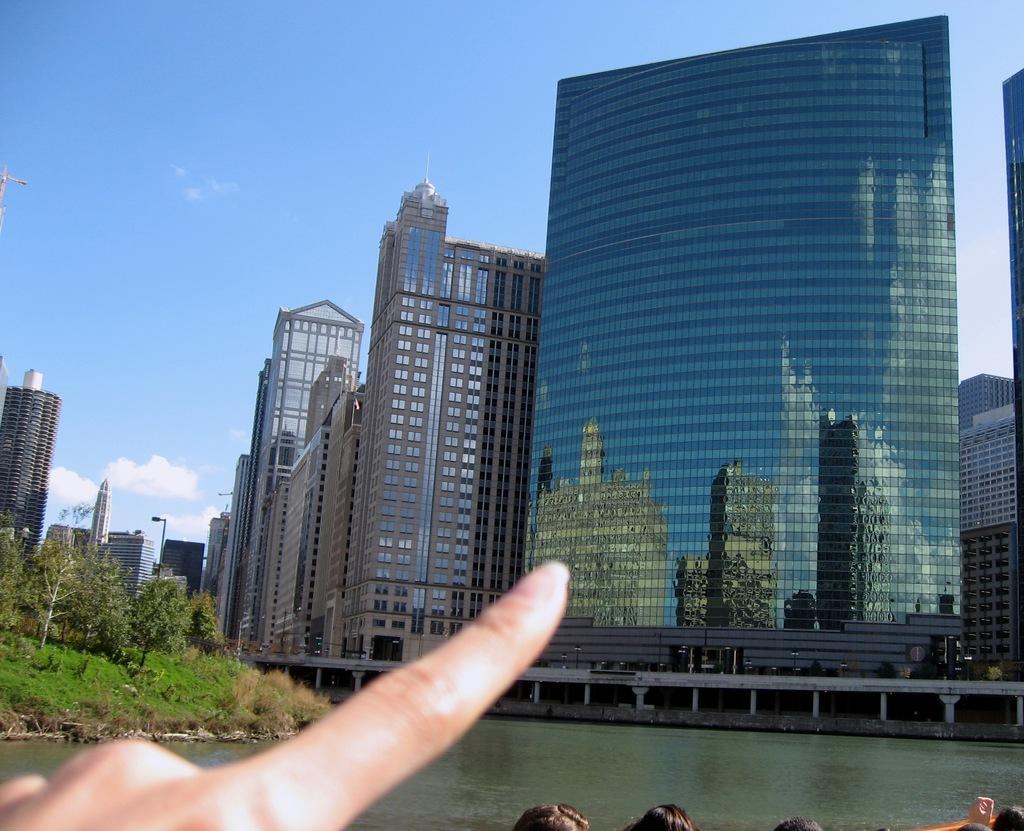Can you describe this image briefly? In this image we can see some person's finger. We can also see many buildings and also trees and grass. At the top there is sky with some clouds and at the bottom we can see the water. 